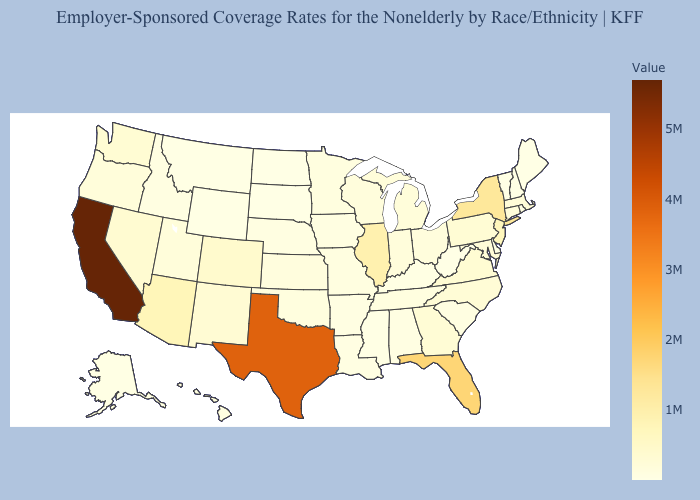Among the states that border New York , does Vermont have the lowest value?
Quick response, please. Yes. Does Minnesota have the lowest value in the MidWest?
Be succinct. No. Does Tennessee have a lower value than New York?
Write a very short answer. Yes. Which states have the highest value in the USA?
Give a very brief answer. California. Does Illinois have the highest value in the MidWest?
Concise answer only. Yes. 